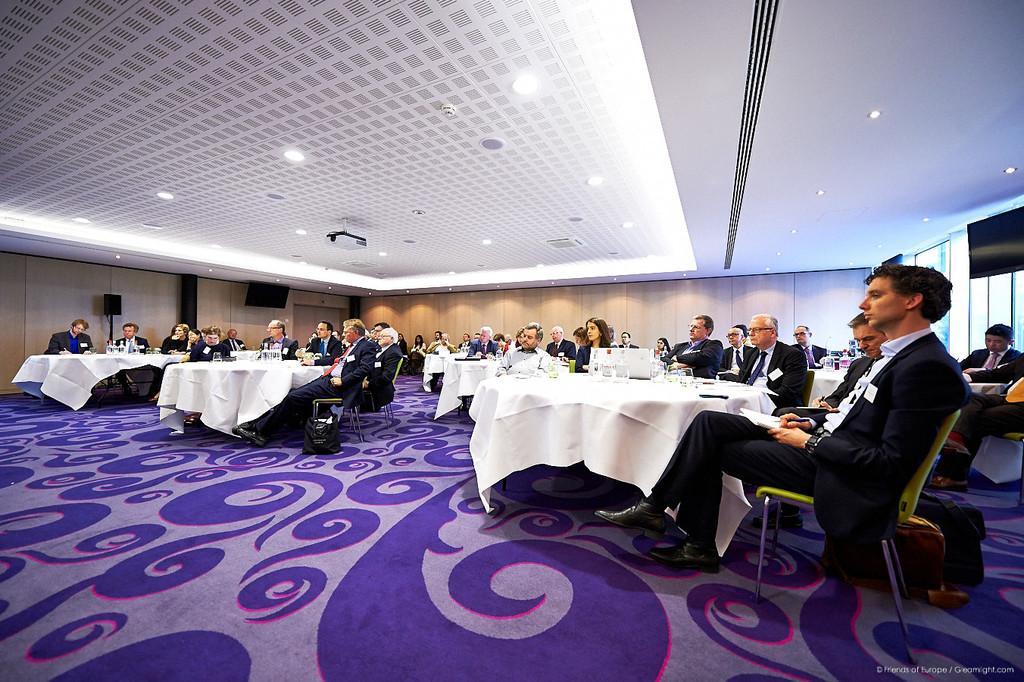Can you describe this image briefly? People are sitting on chairs. In-front of them there are tables. On these tables there are things. Beside this man there are bags. In this room we can see televisions and speaker. Lights are attached to the ceiling.  